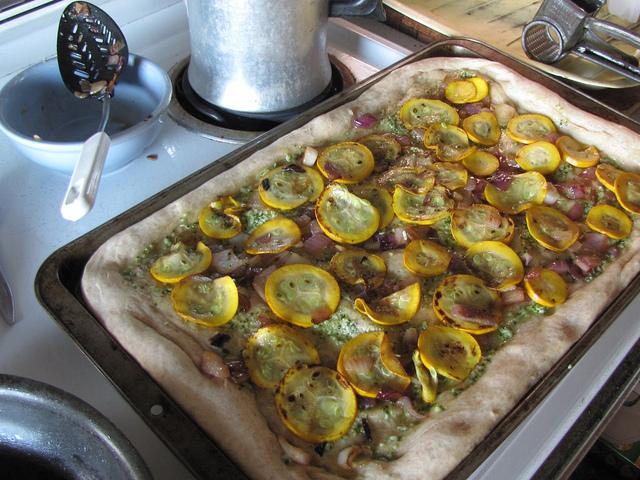Has anyone eaten this food yet?
Quick response, please. No. Is there veggies in the image?
Answer briefly. Yes. Has the spoon been used?
Write a very short answer. Yes. 